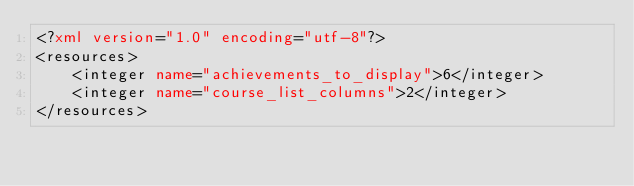Convert code to text. <code><loc_0><loc_0><loc_500><loc_500><_XML_><?xml version="1.0" encoding="utf-8"?>
<resources>
    <integer name="achievements_to_display">6</integer>
    <integer name="course_list_columns">2</integer>
</resources></code> 